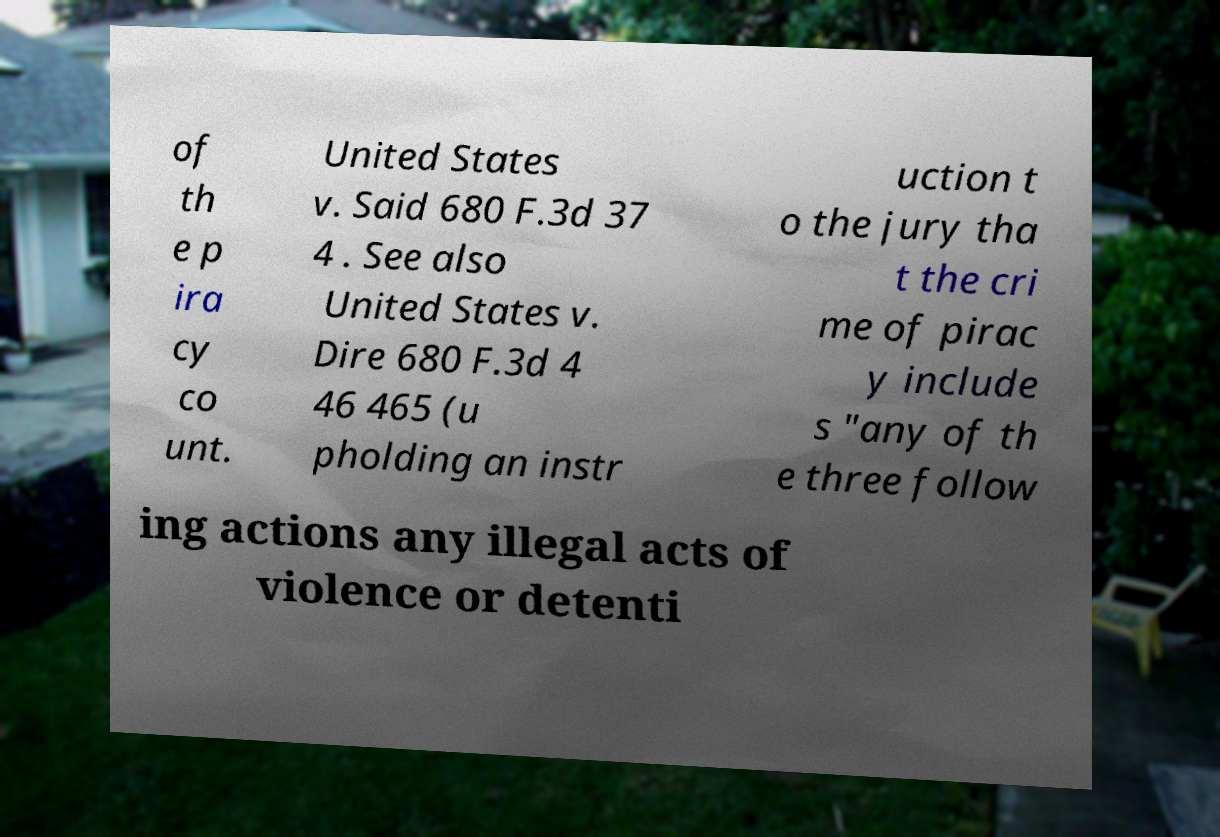Please read and relay the text visible in this image. What does it say? of th e p ira cy co unt. United States v. Said 680 F.3d 37 4 . See also United States v. Dire 680 F.3d 4 46 465 (u pholding an instr uction t o the jury tha t the cri me of pirac y include s "any of th e three follow ing actions any illegal acts of violence or detenti 